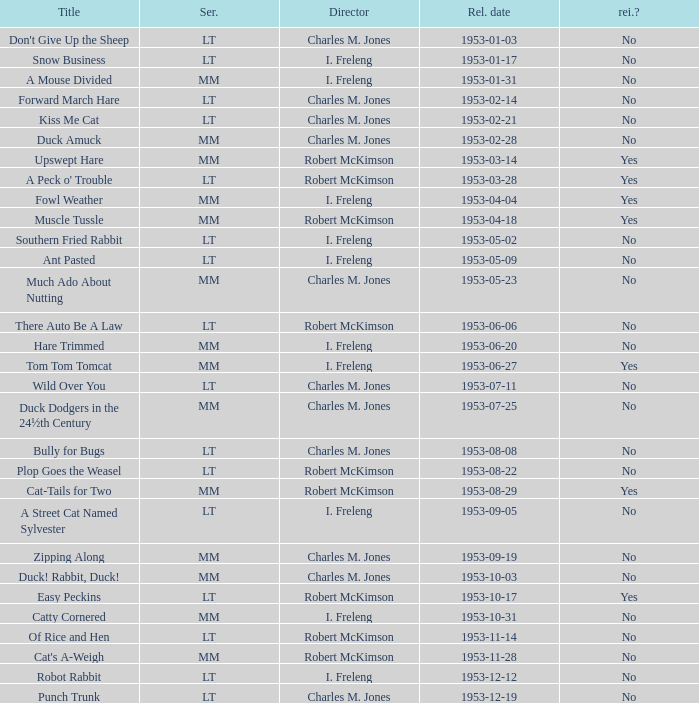Could you parse the entire table? {'header': ['Title', 'Ser.', 'Director', 'Rel. date', 'rei.?'], 'rows': [["Don't Give Up the Sheep", 'LT', 'Charles M. Jones', '1953-01-03', 'No'], ['Snow Business', 'LT', 'I. Freleng', '1953-01-17', 'No'], ['A Mouse Divided', 'MM', 'I. Freleng', '1953-01-31', 'No'], ['Forward March Hare', 'LT', 'Charles M. Jones', '1953-02-14', 'No'], ['Kiss Me Cat', 'LT', 'Charles M. Jones', '1953-02-21', 'No'], ['Duck Amuck', 'MM', 'Charles M. Jones', '1953-02-28', 'No'], ['Upswept Hare', 'MM', 'Robert McKimson', '1953-03-14', 'Yes'], ["A Peck o' Trouble", 'LT', 'Robert McKimson', '1953-03-28', 'Yes'], ['Fowl Weather', 'MM', 'I. Freleng', '1953-04-04', 'Yes'], ['Muscle Tussle', 'MM', 'Robert McKimson', '1953-04-18', 'Yes'], ['Southern Fried Rabbit', 'LT', 'I. Freleng', '1953-05-02', 'No'], ['Ant Pasted', 'LT', 'I. Freleng', '1953-05-09', 'No'], ['Much Ado About Nutting', 'MM', 'Charles M. Jones', '1953-05-23', 'No'], ['There Auto Be A Law', 'LT', 'Robert McKimson', '1953-06-06', 'No'], ['Hare Trimmed', 'MM', 'I. Freleng', '1953-06-20', 'No'], ['Tom Tom Tomcat', 'MM', 'I. Freleng', '1953-06-27', 'Yes'], ['Wild Over You', 'LT', 'Charles M. Jones', '1953-07-11', 'No'], ['Duck Dodgers in the 24½th Century', 'MM', 'Charles M. Jones', '1953-07-25', 'No'], ['Bully for Bugs', 'LT', 'Charles M. Jones', '1953-08-08', 'No'], ['Plop Goes the Weasel', 'LT', 'Robert McKimson', '1953-08-22', 'No'], ['Cat-Tails for Two', 'MM', 'Robert McKimson', '1953-08-29', 'Yes'], ['A Street Cat Named Sylvester', 'LT', 'I. Freleng', '1953-09-05', 'No'], ['Zipping Along', 'MM', 'Charles M. Jones', '1953-09-19', 'No'], ['Duck! Rabbit, Duck!', 'MM', 'Charles M. Jones', '1953-10-03', 'No'], ['Easy Peckins', 'LT', 'Robert McKimson', '1953-10-17', 'Yes'], ['Catty Cornered', 'MM', 'I. Freleng', '1953-10-31', 'No'], ['Of Rice and Hen', 'LT', 'Robert McKimson', '1953-11-14', 'No'], ["Cat's A-Weigh", 'MM', 'Robert McKimson', '1953-11-28', 'No'], ['Robot Rabbit', 'LT', 'I. Freleng', '1953-12-12', 'No'], ['Punch Trunk', 'LT', 'Charles M. Jones', '1953-12-19', 'No']]} What's the release date of Upswept Hare? 1953-03-14. 